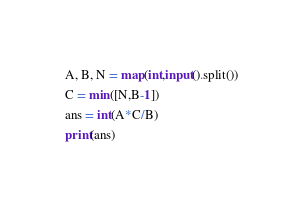<code> <loc_0><loc_0><loc_500><loc_500><_Python_>A, B, N = map(int,input().split())
C = min([N,B-1])
ans = int(A*C/B)
print(ans)

</code> 